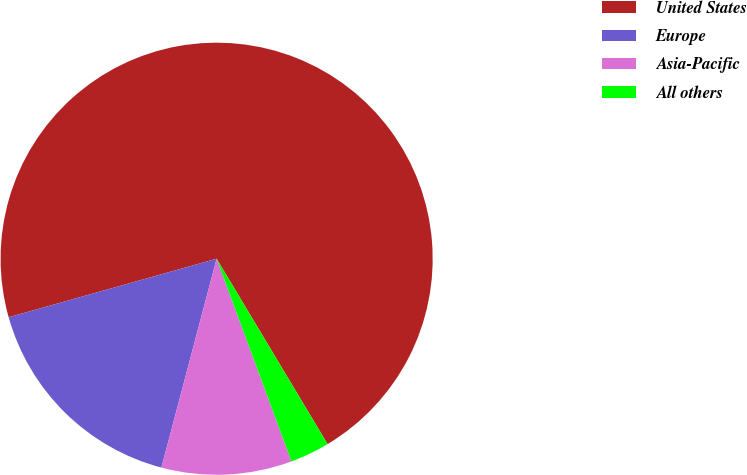Convert chart. <chart><loc_0><loc_0><loc_500><loc_500><pie_chart><fcel>United States<fcel>Europe<fcel>Asia-Pacific<fcel>All others<nl><fcel>70.78%<fcel>16.52%<fcel>9.74%<fcel>2.96%<nl></chart> 